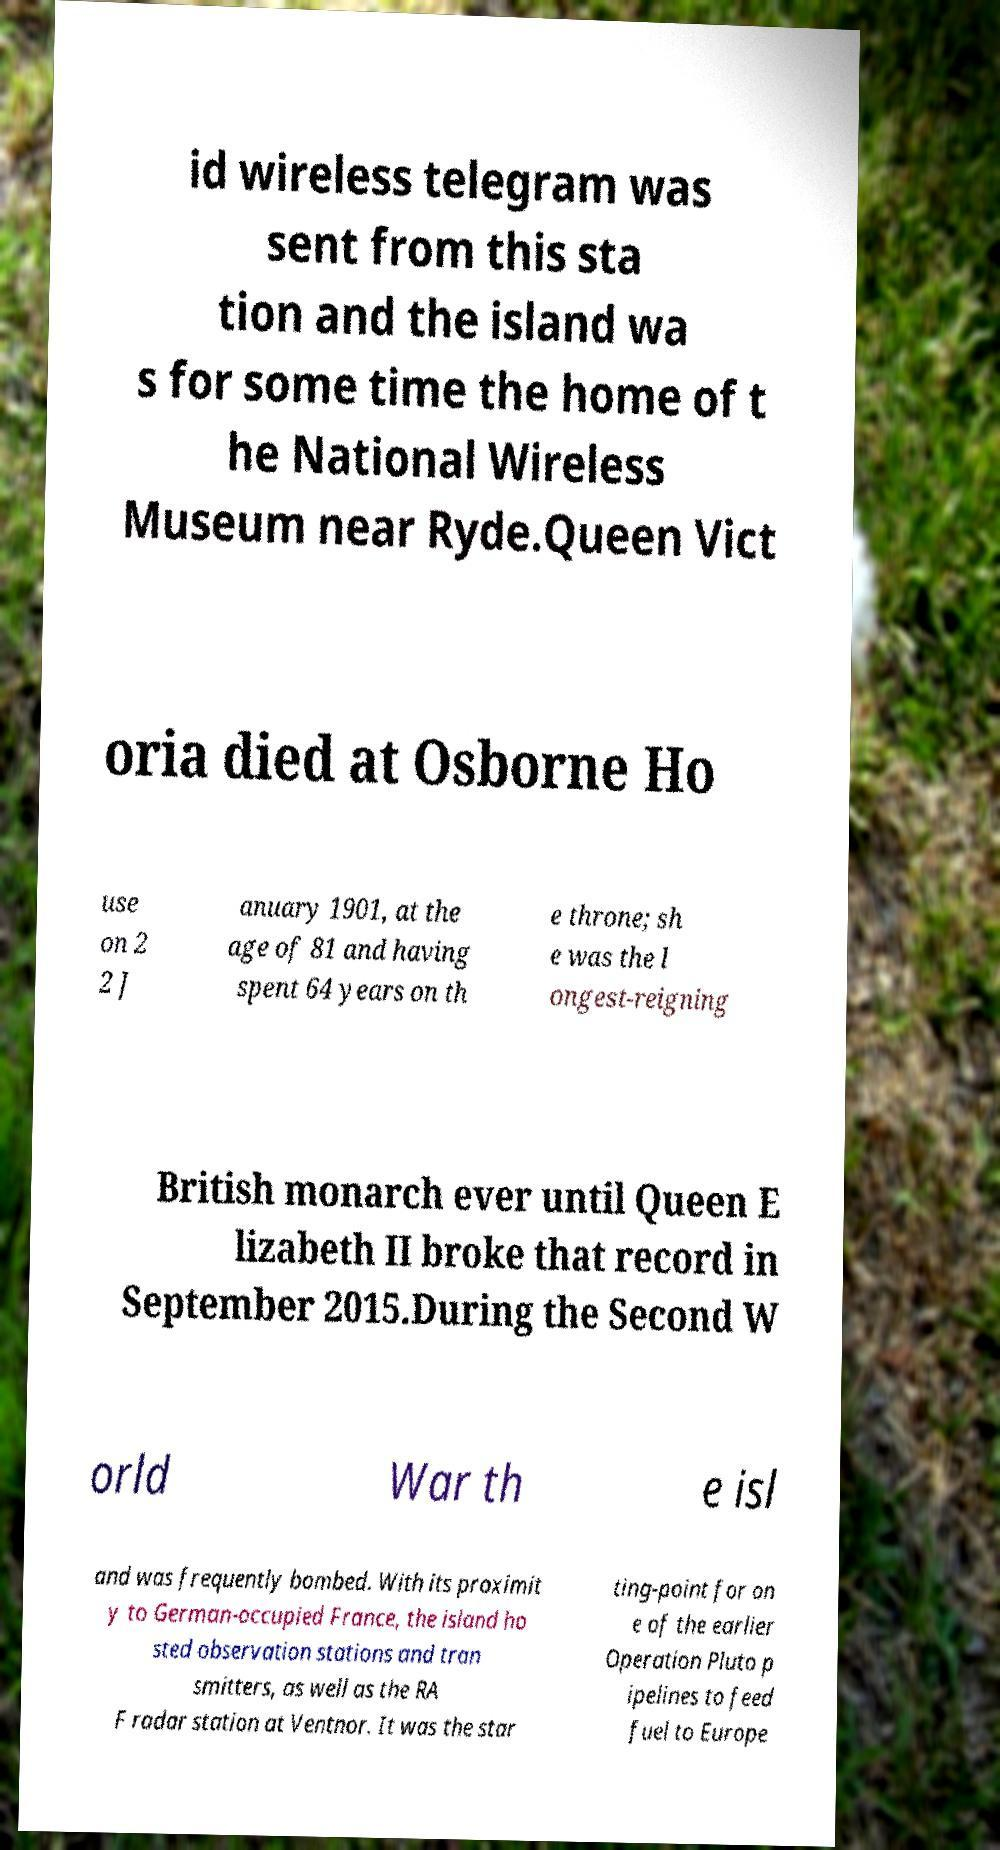There's text embedded in this image that I need extracted. Can you transcribe it verbatim? id wireless telegram was sent from this sta tion and the island wa s for some time the home of t he National Wireless Museum near Ryde.Queen Vict oria died at Osborne Ho use on 2 2 J anuary 1901, at the age of 81 and having spent 64 years on th e throne; sh e was the l ongest-reigning British monarch ever until Queen E lizabeth II broke that record in September 2015.During the Second W orld War th e isl and was frequently bombed. With its proximit y to German-occupied France, the island ho sted observation stations and tran smitters, as well as the RA F radar station at Ventnor. It was the star ting-point for on e of the earlier Operation Pluto p ipelines to feed fuel to Europe 